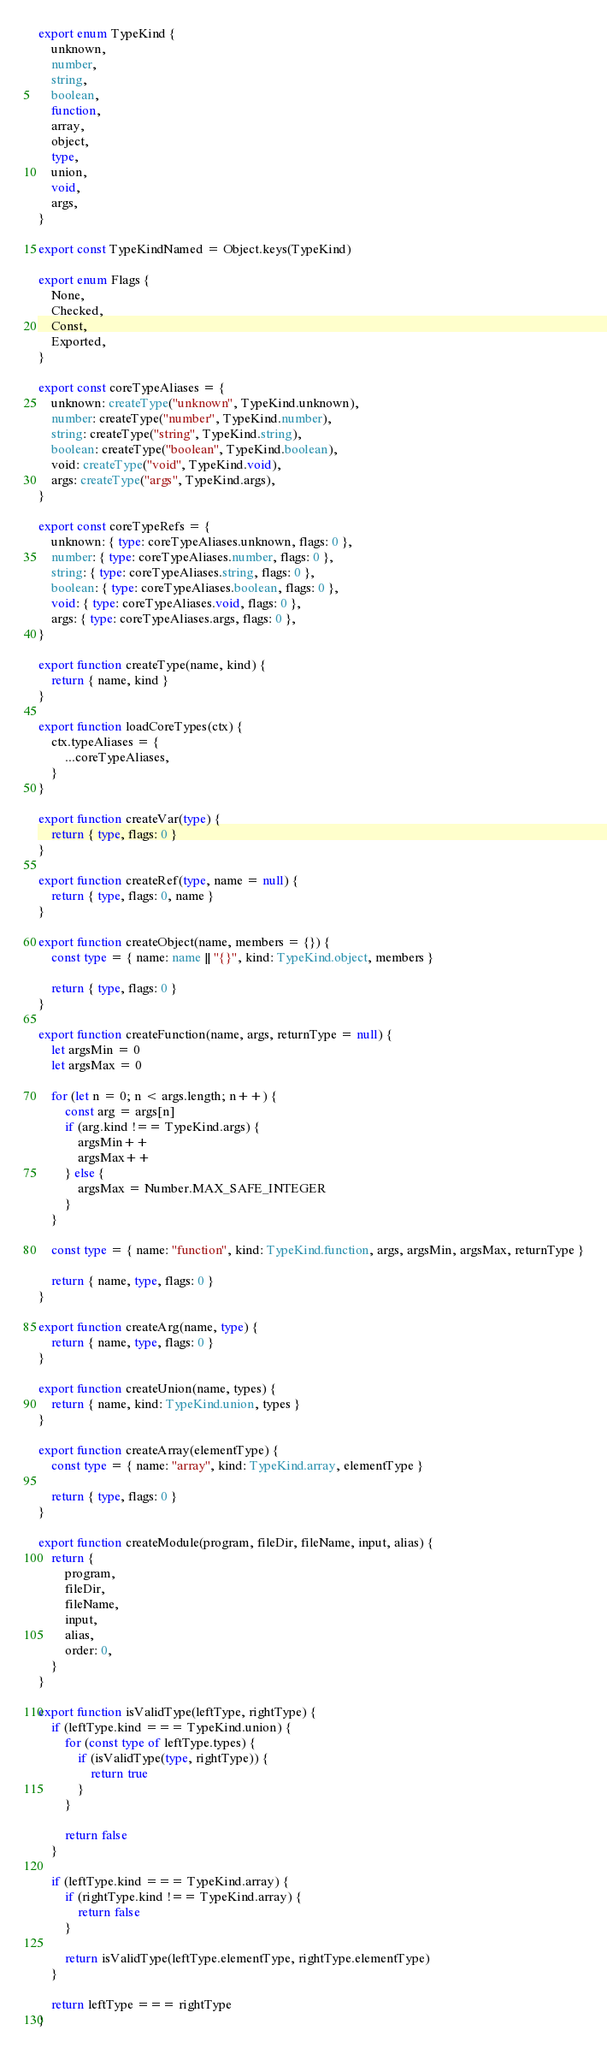<code> <loc_0><loc_0><loc_500><loc_500><_TypeScript_>export enum TypeKind {
    unknown,
    number,
    string,
    boolean,
    function,
    array,
    object,
    type,
    union,
    void,
    args,
}

export const TypeKindNamed = Object.keys(TypeKind)

export enum Flags {
    None,
    Checked,
    Const,
    Exported,
}

export const coreTypeAliases = {
    unknown: createType("unknown", TypeKind.unknown),
    number: createType("number", TypeKind.number),
    string: createType("string", TypeKind.string),
    boolean: createType("boolean", TypeKind.boolean),
    void: createType("void", TypeKind.void),
    args: createType("args", TypeKind.args),
}

export const coreTypeRefs = {
    unknown: { type: coreTypeAliases.unknown, flags: 0 },
    number: { type: coreTypeAliases.number, flags: 0 },
    string: { type: coreTypeAliases.string, flags: 0 },
    boolean: { type: coreTypeAliases.boolean, flags: 0 },
    void: { type: coreTypeAliases.void, flags: 0 },
    args: { type: coreTypeAliases.args, flags: 0 },
}

export function createType(name, kind) {
    return { name, kind }
}

export function loadCoreTypes(ctx) {
    ctx.typeAliases = {
        ...coreTypeAliases,
    }
}

export function createVar(type) {
    return { type, flags: 0 }
}

export function createRef(type, name = null) {
    return { type, flags: 0, name }
}

export function createObject(name, members = {}) {
    const type = { name: name || "{}", kind: TypeKind.object, members }

    return { type, flags: 0 }
}

export function createFunction(name, args, returnType = null) {
    let argsMin = 0
    let argsMax = 0

    for (let n = 0; n < args.length; n++) {
        const arg = args[n]
        if (arg.kind !== TypeKind.args) {
            argsMin++
            argsMax++
        } else {
            argsMax = Number.MAX_SAFE_INTEGER
        }
    }

    const type = { name: "function", kind: TypeKind.function, args, argsMin, argsMax, returnType }

    return { name, type, flags: 0 }
}

export function createArg(name, type) {
    return { name, type, flags: 0 }
}

export function createUnion(name, types) {
    return { name, kind: TypeKind.union, types }
}

export function createArray(elementType) {
    const type = { name: "array", kind: TypeKind.array, elementType }

    return { type, flags: 0 }
}

export function createModule(program, fileDir, fileName, input, alias) {
    return {
        program,
        fileDir,
        fileName,
        input,
        alias,
        order: 0,
    }
}

export function isValidType(leftType, rightType) {
    if (leftType.kind === TypeKind.union) {
        for (const type of leftType.types) {
            if (isValidType(type, rightType)) {
                return true
            }
        }

        return false
    }

    if (leftType.kind === TypeKind.array) {
        if (rightType.kind !== TypeKind.array) {
            return false
        }

        return isValidType(leftType.elementType, rightType.elementType)
    }

    return leftType === rightType
}
</code> 